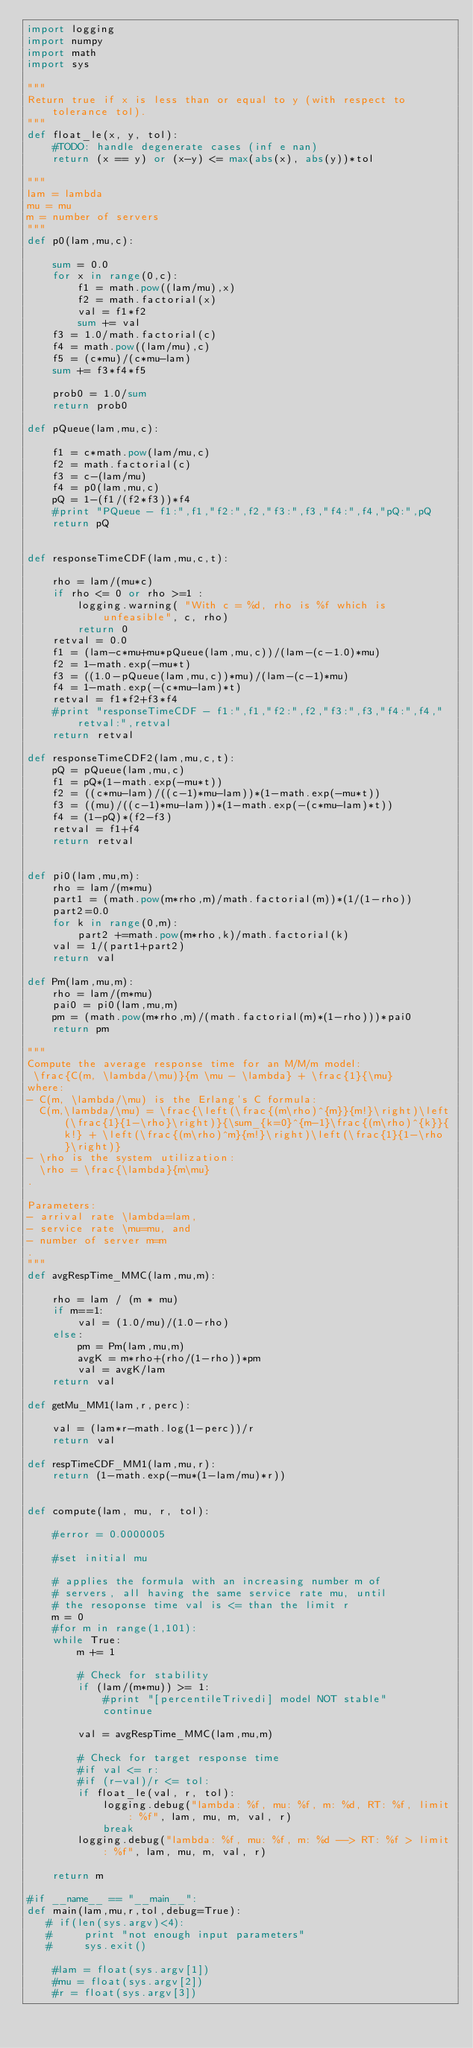Convert code to text. <code><loc_0><loc_0><loc_500><loc_500><_Python_>import logging
import numpy
import math
import sys

"""
Return true if x is less than or equal to y (with respect to tolerance tol).
"""
def float_le(x, y, tol):
    #TODO: handle degenerate cases (inf e nan)
    return (x == y) or (x-y) <= max(abs(x), abs(y))*tol

"""
lam = lambda
mu = mu
m = number of servers
"""
def p0(lam,mu,c):

    sum = 0.0
    for x in range(0,c):
        f1 = math.pow((lam/mu),x)
        f2 = math.factorial(x)
        val = f1*f2
        sum += val
    f3 = 1.0/math.factorial(c)
    f4 = math.pow((lam/mu),c)
    f5 = (c*mu)/(c*mu-lam)
    sum += f3*f4*f5

    prob0 = 1.0/sum
    return prob0

def pQueue(lam,mu,c):

    f1 = c*math.pow(lam/mu,c)
    f2 = math.factorial(c)
    f3 = c-(lam/mu)
    f4 = p0(lam,mu,c)
    pQ = 1-(f1/(f2*f3))*f4
    #print "PQueue - f1:",f1,"f2:",f2,"f3:",f3,"f4:",f4,"pQ:",pQ
    return pQ


def responseTimeCDF(lam,mu,c,t):

    rho = lam/(mu*c)
    if rho <= 0 or rho >=1 :
        logging.warning( "With c = %d, rho is %f which is unfeasible", c, rho)
        return 0
    retval = 0.0
    f1 = (lam-c*mu+mu*pQueue(lam,mu,c))/(lam-(c-1.0)*mu)
    f2 = 1-math.exp(-mu*t)
    f3 = ((1.0-pQueue(lam,mu,c))*mu)/(lam-(c-1)*mu)
    f4 = 1-math.exp(-(c*mu-lam)*t)
    retval = f1*f2+f3*f4
    #print "responseTimeCDF - f1:",f1,"f2:",f2,"f3:",f3,"f4:",f4,"retval:",retval
    return retval

def responseTimeCDF2(lam,mu,c,t):
    pQ = pQueue(lam,mu,c)
    f1 = pQ*(1-math.exp(-mu*t))
    f2 = ((c*mu-lam)/((c-1)*mu-lam))*(1-math.exp(-mu*t))
    f3 = ((mu)/((c-1)*mu-lam))*(1-math.exp(-(c*mu-lam)*t))
    f4 = (1-pQ)*(f2-f3)
    retval = f1+f4
    return retval


def pi0(lam,mu,m):
    rho = lam/(m*mu)
    part1 = (math.pow(m*rho,m)/math.factorial(m))*(1/(1-rho))
    part2=0.0
    for k in range(0,m):
        part2 +=math.pow(m*rho,k)/math.factorial(k)
    val = 1/(part1+part2)
    return val

def Pm(lam,mu,m):
    rho = lam/(m*mu)
    pai0 = pi0(lam,mu,m)
    pm = (math.pow(m*rho,m)/(math.factorial(m)*(1-rho)))*pai0
    return pm

"""
Compute the average response time for an M/M/m model:
 \frac{C(m, \lambda/\mu)}{m \mu - \lambda} + \frac{1}{\mu}
where:
- C(m, \lambda/\mu) is the Erlang's C formula:
  C(m,\lambda/\mu) = \frac{\left(\frac{(m\rho)^{m}}{m!}\right)\left(\frac{1}{1-\rho}\right)}{\sum_{k=0}^{m-1}\frac{(m\rho)^{k}}{k!} + \left(\frac{(m\rho)^m}{m!}\right)\left(\frac{1}{1-\rho}\right)}
- \rho is the system utilization:
  \rho = \frac{\lambda}{m\mu}
.

Parameters:
- arrival rate \lambda=lam,
- service rate \mu=mu, and
- number of server m=m
.
"""
def avgRespTime_MMC(lam,mu,m):

    rho = lam / (m * mu)
    if m==1:
        val = (1.0/mu)/(1.0-rho)
    else:
        pm = Pm(lam,mu,m)
        avgK = m*rho+(rho/(1-rho))*pm
        val = avgK/lam
    return val

def getMu_MM1(lam,r,perc):

    val = (lam*r-math.log(1-perc))/r
    return val

def respTimeCDF_MM1(lam,mu,r):
    return (1-math.exp(-mu*(1-lam/mu)*r))


def compute(lam, mu, r, tol):

    #error = 0.0000005

    #set initial mu

    # applies the formula with an increasing number m of
    # servers, all having the same service rate mu, until
    # the resoponse time val is <= than the limit r
    m = 0
    #for m in range(1,101):
    while True:
        m += 1

        # Check for stability
        if (lam/(m*mu)) >= 1:
            #print "[percentileTrivedi] model NOT stable"
            continue

        val = avgRespTime_MMC(lam,mu,m)

        # Check for target response time
        #if val <= r:
        #if (r-val)/r <= tol:
        if float_le(val, r, tol):
            logging.debug("lambda: %f, mu: %f, m: %d, RT: %f, limit: %f", lam, mu, m, val, r)
            break
        logging.debug("lambda: %f, mu: %f, m: %d --> RT: %f > limit: %f", lam, mu, m, val, r)

    return m

#if __name__ == "__main__":
def main(lam,mu,r,tol,debug=True):
   # if(len(sys.argv)<4):
   #     print "not enough input parameters"
   #     sys.exit()
    
    #lam = float(sys.argv[1])
    #mu = float(sys.argv[2])
    #r = float(sys.argv[3])
</code> 